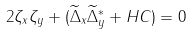<formula> <loc_0><loc_0><loc_500><loc_500>2 \zeta _ { x } \zeta _ { y } + ( \widetilde { \Delta } _ { x } \widetilde { \Delta } _ { y } ^ { \ast } + H C ) = 0</formula> 